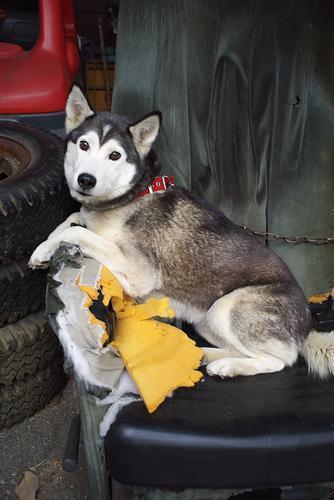How many dogs are in this picture?
Give a very brief answer. 1. 